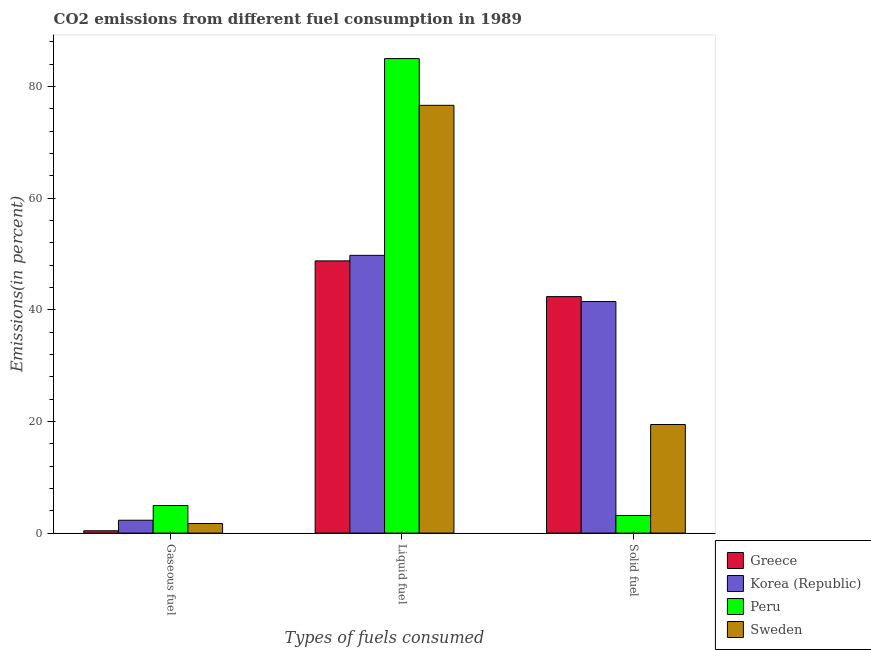How many different coloured bars are there?
Your response must be concise. 4. How many groups of bars are there?
Offer a very short reply. 3. Are the number of bars per tick equal to the number of legend labels?
Give a very brief answer. Yes. How many bars are there on the 1st tick from the left?
Provide a succinct answer. 4. How many bars are there on the 2nd tick from the right?
Your answer should be compact. 4. What is the label of the 2nd group of bars from the left?
Keep it short and to the point. Liquid fuel. What is the percentage of gaseous fuel emission in Greece?
Provide a short and direct response. 0.42. Across all countries, what is the maximum percentage of liquid fuel emission?
Offer a terse response. 85.02. Across all countries, what is the minimum percentage of liquid fuel emission?
Keep it short and to the point. 48.77. What is the total percentage of liquid fuel emission in the graph?
Make the answer very short. 260.21. What is the difference between the percentage of liquid fuel emission in Greece and that in Sweden?
Give a very brief answer. -27.88. What is the difference between the percentage of gaseous fuel emission in Sweden and the percentage of solid fuel emission in Greece?
Offer a terse response. -40.66. What is the average percentage of liquid fuel emission per country?
Provide a succinct answer. 65.05. What is the difference between the percentage of liquid fuel emission and percentage of gaseous fuel emission in Greece?
Make the answer very short. 48.36. What is the ratio of the percentage of liquid fuel emission in Peru to that in Sweden?
Provide a short and direct response. 1.11. Is the percentage of solid fuel emission in Sweden less than that in Greece?
Offer a very short reply. Yes. Is the difference between the percentage of solid fuel emission in Peru and Greece greater than the difference between the percentage of gaseous fuel emission in Peru and Greece?
Provide a succinct answer. No. What is the difference between the highest and the second highest percentage of gaseous fuel emission?
Offer a terse response. 2.64. What is the difference between the highest and the lowest percentage of gaseous fuel emission?
Keep it short and to the point. 4.52. Is the sum of the percentage of solid fuel emission in Greece and Peru greater than the maximum percentage of liquid fuel emission across all countries?
Give a very brief answer. No. What does the 4th bar from the left in Liquid fuel represents?
Give a very brief answer. Sweden. What does the 1st bar from the right in Gaseous fuel represents?
Give a very brief answer. Sweden. How many bars are there?
Provide a succinct answer. 12. Are all the bars in the graph horizontal?
Offer a very short reply. No. How many countries are there in the graph?
Keep it short and to the point. 4. Are the values on the major ticks of Y-axis written in scientific E-notation?
Provide a succinct answer. No. Does the graph contain any zero values?
Your answer should be very brief. No. Where does the legend appear in the graph?
Make the answer very short. Bottom right. How many legend labels are there?
Make the answer very short. 4. What is the title of the graph?
Ensure brevity in your answer.  CO2 emissions from different fuel consumption in 1989. Does "Swaziland" appear as one of the legend labels in the graph?
Your response must be concise. No. What is the label or title of the X-axis?
Ensure brevity in your answer.  Types of fuels consumed. What is the label or title of the Y-axis?
Offer a terse response. Emissions(in percent). What is the Emissions(in percent) in Greece in Gaseous fuel?
Provide a short and direct response. 0.42. What is the Emissions(in percent) of Korea (Republic) in Gaseous fuel?
Ensure brevity in your answer.  2.3. What is the Emissions(in percent) of Peru in Gaseous fuel?
Offer a very short reply. 4.94. What is the Emissions(in percent) in Sweden in Gaseous fuel?
Give a very brief answer. 1.71. What is the Emissions(in percent) in Greece in Liquid fuel?
Offer a very short reply. 48.77. What is the Emissions(in percent) in Korea (Republic) in Liquid fuel?
Give a very brief answer. 49.77. What is the Emissions(in percent) of Peru in Liquid fuel?
Provide a short and direct response. 85.02. What is the Emissions(in percent) in Sweden in Liquid fuel?
Your answer should be compact. 76.65. What is the Emissions(in percent) of Greece in Solid fuel?
Give a very brief answer. 42.37. What is the Emissions(in percent) in Korea (Republic) in Solid fuel?
Ensure brevity in your answer.  41.49. What is the Emissions(in percent) in Peru in Solid fuel?
Offer a very short reply. 3.16. What is the Emissions(in percent) of Sweden in Solid fuel?
Give a very brief answer. 19.45. Across all Types of fuels consumed, what is the maximum Emissions(in percent) of Greece?
Keep it short and to the point. 48.77. Across all Types of fuels consumed, what is the maximum Emissions(in percent) of Korea (Republic)?
Your answer should be compact. 49.77. Across all Types of fuels consumed, what is the maximum Emissions(in percent) in Peru?
Ensure brevity in your answer.  85.02. Across all Types of fuels consumed, what is the maximum Emissions(in percent) of Sweden?
Offer a very short reply. 76.65. Across all Types of fuels consumed, what is the minimum Emissions(in percent) of Greece?
Give a very brief answer. 0.42. Across all Types of fuels consumed, what is the minimum Emissions(in percent) in Korea (Republic)?
Offer a terse response. 2.3. Across all Types of fuels consumed, what is the minimum Emissions(in percent) in Peru?
Your answer should be compact. 3.16. Across all Types of fuels consumed, what is the minimum Emissions(in percent) in Sweden?
Keep it short and to the point. 1.71. What is the total Emissions(in percent) of Greece in the graph?
Offer a very short reply. 91.56. What is the total Emissions(in percent) of Korea (Republic) in the graph?
Offer a terse response. 93.56. What is the total Emissions(in percent) in Peru in the graph?
Your response must be concise. 93.12. What is the total Emissions(in percent) in Sweden in the graph?
Your answer should be compact. 97.81. What is the difference between the Emissions(in percent) in Greece in Gaseous fuel and that in Liquid fuel?
Offer a very short reply. -48.36. What is the difference between the Emissions(in percent) of Korea (Republic) in Gaseous fuel and that in Liquid fuel?
Ensure brevity in your answer.  -47.46. What is the difference between the Emissions(in percent) in Peru in Gaseous fuel and that in Liquid fuel?
Provide a short and direct response. -80.09. What is the difference between the Emissions(in percent) of Sweden in Gaseous fuel and that in Liquid fuel?
Make the answer very short. -74.94. What is the difference between the Emissions(in percent) of Greece in Gaseous fuel and that in Solid fuel?
Your answer should be very brief. -41.96. What is the difference between the Emissions(in percent) of Korea (Republic) in Gaseous fuel and that in Solid fuel?
Your answer should be compact. -39.19. What is the difference between the Emissions(in percent) in Peru in Gaseous fuel and that in Solid fuel?
Provide a succinct answer. 1.78. What is the difference between the Emissions(in percent) in Sweden in Gaseous fuel and that in Solid fuel?
Offer a very short reply. -17.74. What is the difference between the Emissions(in percent) in Greece in Liquid fuel and that in Solid fuel?
Provide a short and direct response. 6.4. What is the difference between the Emissions(in percent) of Korea (Republic) in Liquid fuel and that in Solid fuel?
Give a very brief answer. 8.27. What is the difference between the Emissions(in percent) in Peru in Liquid fuel and that in Solid fuel?
Your answer should be compact. 81.87. What is the difference between the Emissions(in percent) in Sweden in Liquid fuel and that in Solid fuel?
Offer a terse response. 57.2. What is the difference between the Emissions(in percent) of Greece in Gaseous fuel and the Emissions(in percent) of Korea (Republic) in Liquid fuel?
Offer a terse response. -49.35. What is the difference between the Emissions(in percent) of Greece in Gaseous fuel and the Emissions(in percent) of Peru in Liquid fuel?
Offer a terse response. -84.61. What is the difference between the Emissions(in percent) in Greece in Gaseous fuel and the Emissions(in percent) in Sweden in Liquid fuel?
Your response must be concise. -76.24. What is the difference between the Emissions(in percent) of Korea (Republic) in Gaseous fuel and the Emissions(in percent) of Peru in Liquid fuel?
Give a very brief answer. -82.72. What is the difference between the Emissions(in percent) of Korea (Republic) in Gaseous fuel and the Emissions(in percent) of Sweden in Liquid fuel?
Offer a very short reply. -74.35. What is the difference between the Emissions(in percent) of Peru in Gaseous fuel and the Emissions(in percent) of Sweden in Liquid fuel?
Give a very brief answer. -71.71. What is the difference between the Emissions(in percent) of Greece in Gaseous fuel and the Emissions(in percent) of Korea (Republic) in Solid fuel?
Offer a very short reply. -41.08. What is the difference between the Emissions(in percent) in Greece in Gaseous fuel and the Emissions(in percent) in Peru in Solid fuel?
Provide a short and direct response. -2.74. What is the difference between the Emissions(in percent) in Greece in Gaseous fuel and the Emissions(in percent) in Sweden in Solid fuel?
Provide a short and direct response. -19.04. What is the difference between the Emissions(in percent) of Korea (Republic) in Gaseous fuel and the Emissions(in percent) of Peru in Solid fuel?
Provide a short and direct response. -0.86. What is the difference between the Emissions(in percent) in Korea (Republic) in Gaseous fuel and the Emissions(in percent) in Sweden in Solid fuel?
Offer a terse response. -17.15. What is the difference between the Emissions(in percent) in Peru in Gaseous fuel and the Emissions(in percent) in Sweden in Solid fuel?
Provide a succinct answer. -14.52. What is the difference between the Emissions(in percent) of Greece in Liquid fuel and the Emissions(in percent) of Korea (Republic) in Solid fuel?
Provide a short and direct response. 7.28. What is the difference between the Emissions(in percent) in Greece in Liquid fuel and the Emissions(in percent) in Peru in Solid fuel?
Give a very brief answer. 45.62. What is the difference between the Emissions(in percent) of Greece in Liquid fuel and the Emissions(in percent) of Sweden in Solid fuel?
Your response must be concise. 29.32. What is the difference between the Emissions(in percent) in Korea (Republic) in Liquid fuel and the Emissions(in percent) in Peru in Solid fuel?
Your answer should be very brief. 46.61. What is the difference between the Emissions(in percent) of Korea (Republic) in Liquid fuel and the Emissions(in percent) of Sweden in Solid fuel?
Provide a short and direct response. 30.31. What is the difference between the Emissions(in percent) of Peru in Liquid fuel and the Emissions(in percent) of Sweden in Solid fuel?
Provide a succinct answer. 65.57. What is the average Emissions(in percent) in Greece per Types of fuels consumed?
Keep it short and to the point. 30.52. What is the average Emissions(in percent) in Korea (Republic) per Types of fuels consumed?
Provide a short and direct response. 31.19. What is the average Emissions(in percent) of Peru per Types of fuels consumed?
Your response must be concise. 31.04. What is the average Emissions(in percent) of Sweden per Types of fuels consumed?
Give a very brief answer. 32.6. What is the difference between the Emissions(in percent) of Greece and Emissions(in percent) of Korea (Republic) in Gaseous fuel?
Offer a very short reply. -1.89. What is the difference between the Emissions(in percent) of Greece and Emissions(in percent) of Peru in Gaseous fuel?
Keep it short and to the point. -4.52. What is the difference between the Emissions(in percent) in Greece and Emissions(in percent) in Sweden in Gaseous fuel?
Your answer should be compact. -1.29. What is the difference between the Emissions(in percent) of Korea (Republic) and Emissions(in percent) of Peru in Gaseous fuel?
Make the answer very short. -2.64. What is the difference between the Emissions(in percent) of Korea (Republic) and Emissions(in percent) of Sweden in Gaseous fuel?
Give a very brief answer. 0.59. What is the difference between the Emissions(in percent) of Peru and Emissions(in percent) of Sweden in Gaseous fuel?
Provide a short and direct response. 3.23. What is the difference between the Emissions(in percent) of Greece and Emissions(in percent) of Korea (Republic) in Liquid fuel?
Offer a very short reply. -0.99. What is the difference between the Emissions(in percent) of Greece and Emissions(in percent) of Peru in Liquid fuel?
Your response must be concise. -36.25. What is the difference between the Emissions(in percent) of Greece and Emissions(in percent) of Sweden in Liquid fuel?
Keep it short and to the point. -27.88. What is the difference between the Emissions(in percent) in Korea (Republic) and Emissions(in percent) in Peru in Liquid fuel?
Your response must be concise. -35.26. What is the difference between the Emissions(in percent) in Korea (Republic) and Emissions(in percent) in Sweden in Liquid fuel?
Offer a very short reply. -26.89. What is the difference between the Emissions(in percent) of Peru and Emissions(in percent) of Sweden in Liquid fuel?
Give a very brief answer. 8.37. What is the difference between the Emissions(in percent) in Greece and Emissions(in percent) in Korea (Republic) in Solid fuel?
Your response must be concise. 0.88. What is the difference between the Emissions(in percent) of Greece and Emissions(in percent) of Peru in Solid fuel?
Provide a succinct answer. 39.22. What is the difference between the Emissions(in percent) in Greece and Emissions(in percent) in Sweden in Solid fuel?
Give a very brief answer. 22.92. What is the difference between the Emissions(in percent) in Korea (Republic) and Emissions(in percent) in Peru in Solid fuel?
Your response must be concise. 38.33. What is the difference between the Emissions(in percent) in Korea (Republic) and Emissions(in percent) in Sweden in Solid fuel?
Ensure brevity in your answer.  22.04. What is the difference between the Emissions(in percent) of Peru and Emissions(in percent) of Sweden in Solid fuel?
Your response must be concise. -16.3. What is the ratio of the Emissions(in percent) in Greece in Gaseous fuel to that in Liquid fuel?
Give a very brief answer. 0.01. What is the ratio of the Emissions(in percent) of Korea (Republic) in Gaseous fuel to that in Liquid fuel?
Make the answer very short. 0.05. What is the ratio of the Emissions(in percent) of Peru in Gaseous fuel to that in Liquid fuel?
Offer a terse response. 0.06. What is the ratio of the Emissions(in percent) of Sweden in Gaseous fuel to that in Liquid fuel?
Give a very brief answer. 0.02. What is the ratio of the Emissions(in percent) of Greece in Gaseous fuel to that in Solid fuel?
Keep it short and to the point. 0.01. What is the ratio of the Emissions(in percent) of Korea (Republic) in Gaseous fuel to that in Solid fuel?
Provide a short and direct response. 0.06. What is the ratio of the Emissions(in percent) in Peru in Gaseous fuel to that in Solid fuel?
Your response must be concise. 1.56. What is the ratio of the Emissions(in percent) of Sweden in Gaseous fuel to that in Solid fuel?
Make the answer very short. 0.09. What is the ratio of the Emissions(in percent) in Greece in Liquid fuel to that in Solid fuel?
Keep it short and to the point. 1.15. What is the ratio of the Emissions(in percent) of Korea (Republic) in Liquid fuel to that in Solid fuel?
Your response must be concise. 1.2. What is the ratio of the Emissions(in percent) of Peru in Liquid fuel to that in Solid fuel?
Ensure brevity in your answer.  26.94. What is the ratio of the Emissions(in percent) of Sweden in Liquid fuel to that in Solid fuel?
Make the answer very short. 3.94. What is the difference between the highest and the second highest Emissions(in percent) in Greece?
Give a very brief answer. 6.4. What is the difference between the highest and the second highest Emissions(in percent) of Korea (Republic)?
Make the answer very short. 8.27. What is the difference between the highest and the second highest Emissions(in percent) in Peru?
Provide a succinct answer. 80.09. What is the difference between the highest and the second highest Emissions(in percent) of Sweden?
Make the answer very short. 57.2. What is the difference between the highest and the lowest Emissions(in percent) in Greece?
Make the answer very short. 48.36. What is the difference between the highest and the lowest Emissions(in percent) in Korea (Republic)?
Make the answer very short. 47.46. What is the difference between the highest and the lowest Emissions(in percent) of Peru?
Offer a very short reply. 81.87. What is the difference between the highest and the lowest Emissions(in percent) of Sweden?
Keep it short and to the point. 74.94. 